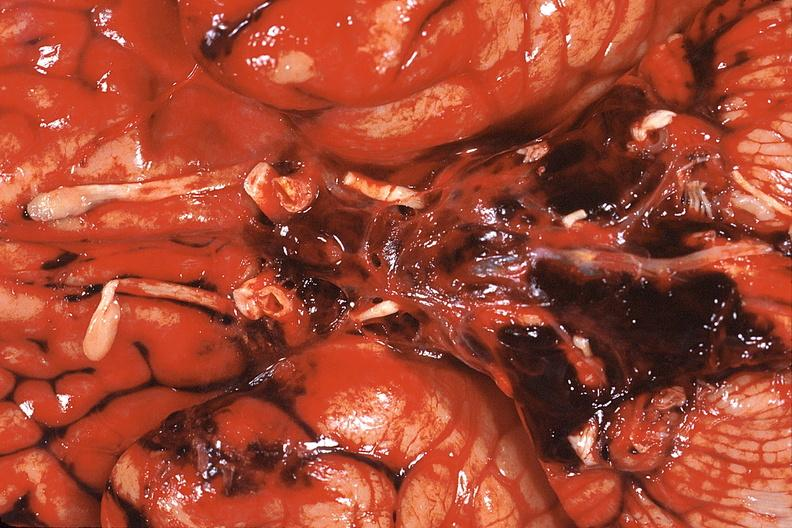does infarction secondary to shock show brain, edema herniation right cingulate gyrus?
Answer the question using a single word or phrase. No 